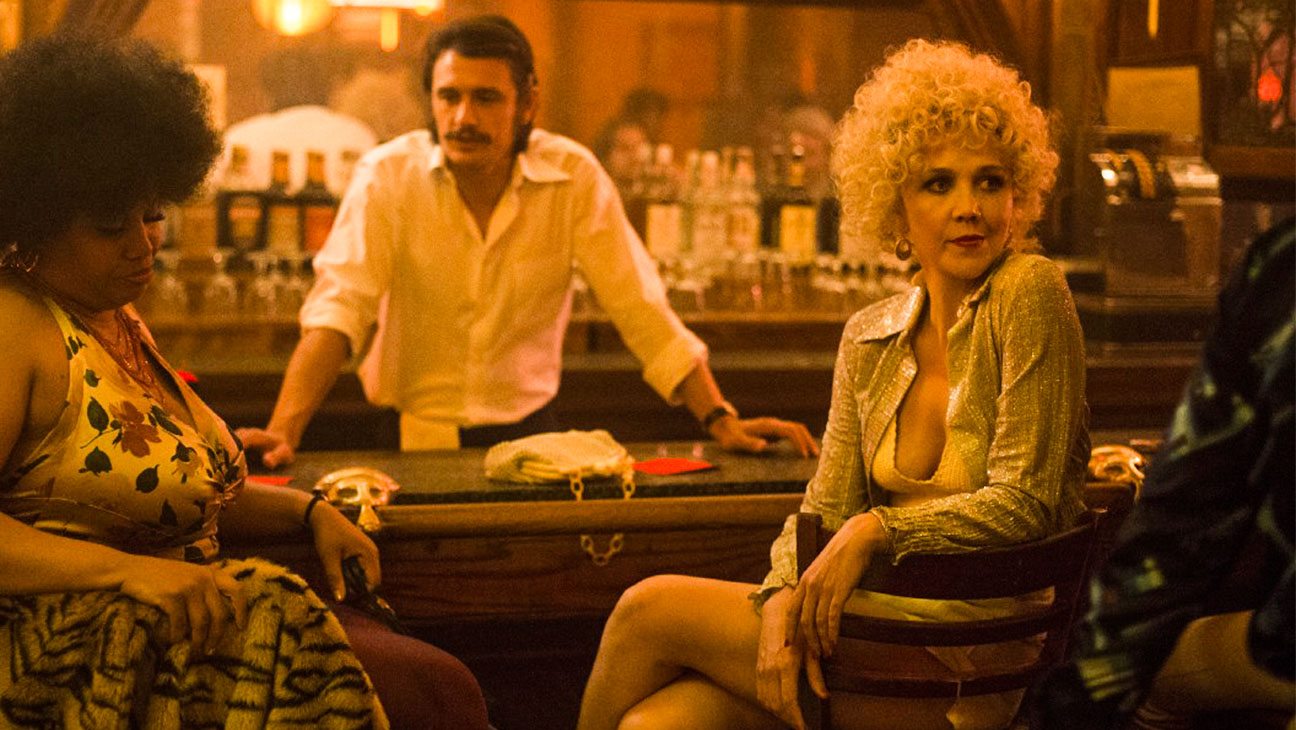What era or time period does this scene likely represent? This scene likely represents the 1970s, as indicated by the fashion and hairstyles of the characters. The woman's gold sequin jacket and curly blonde wig, along with the floral patterns and afro hairstyle of the second woman, and the white shirt and mustache of the man, are characteristic styles of that decade. 